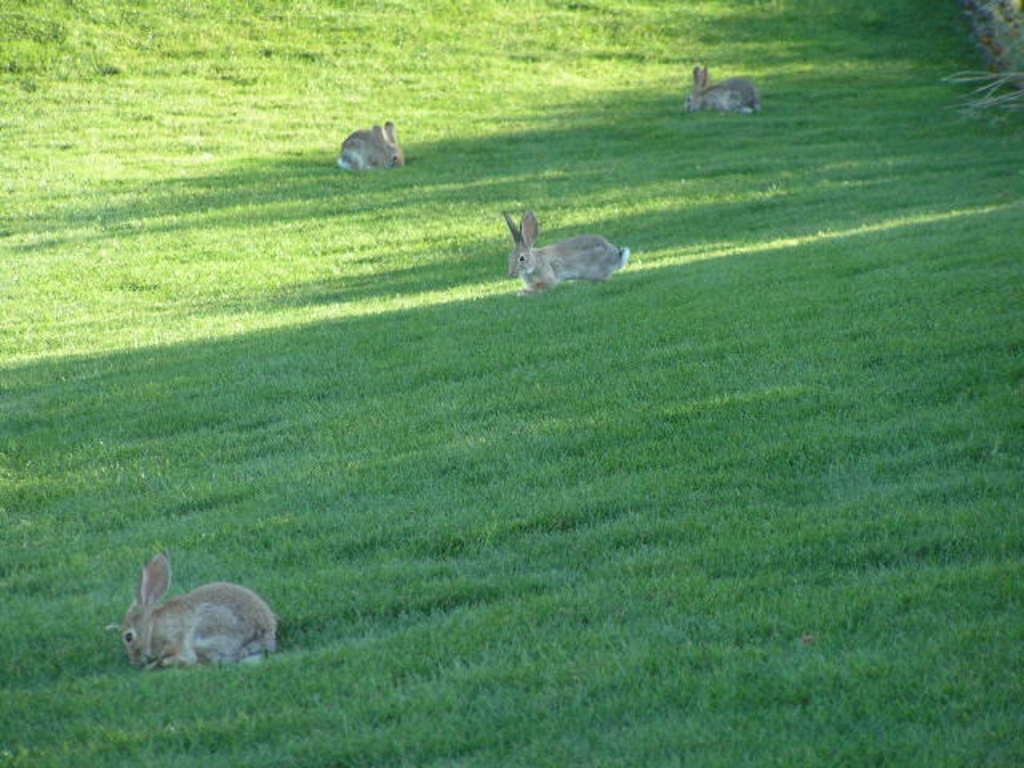Describe this image in one or two sentences. In this image there are four rabbits on the ground. On the ground there is grass. On the right side top there are plants. 